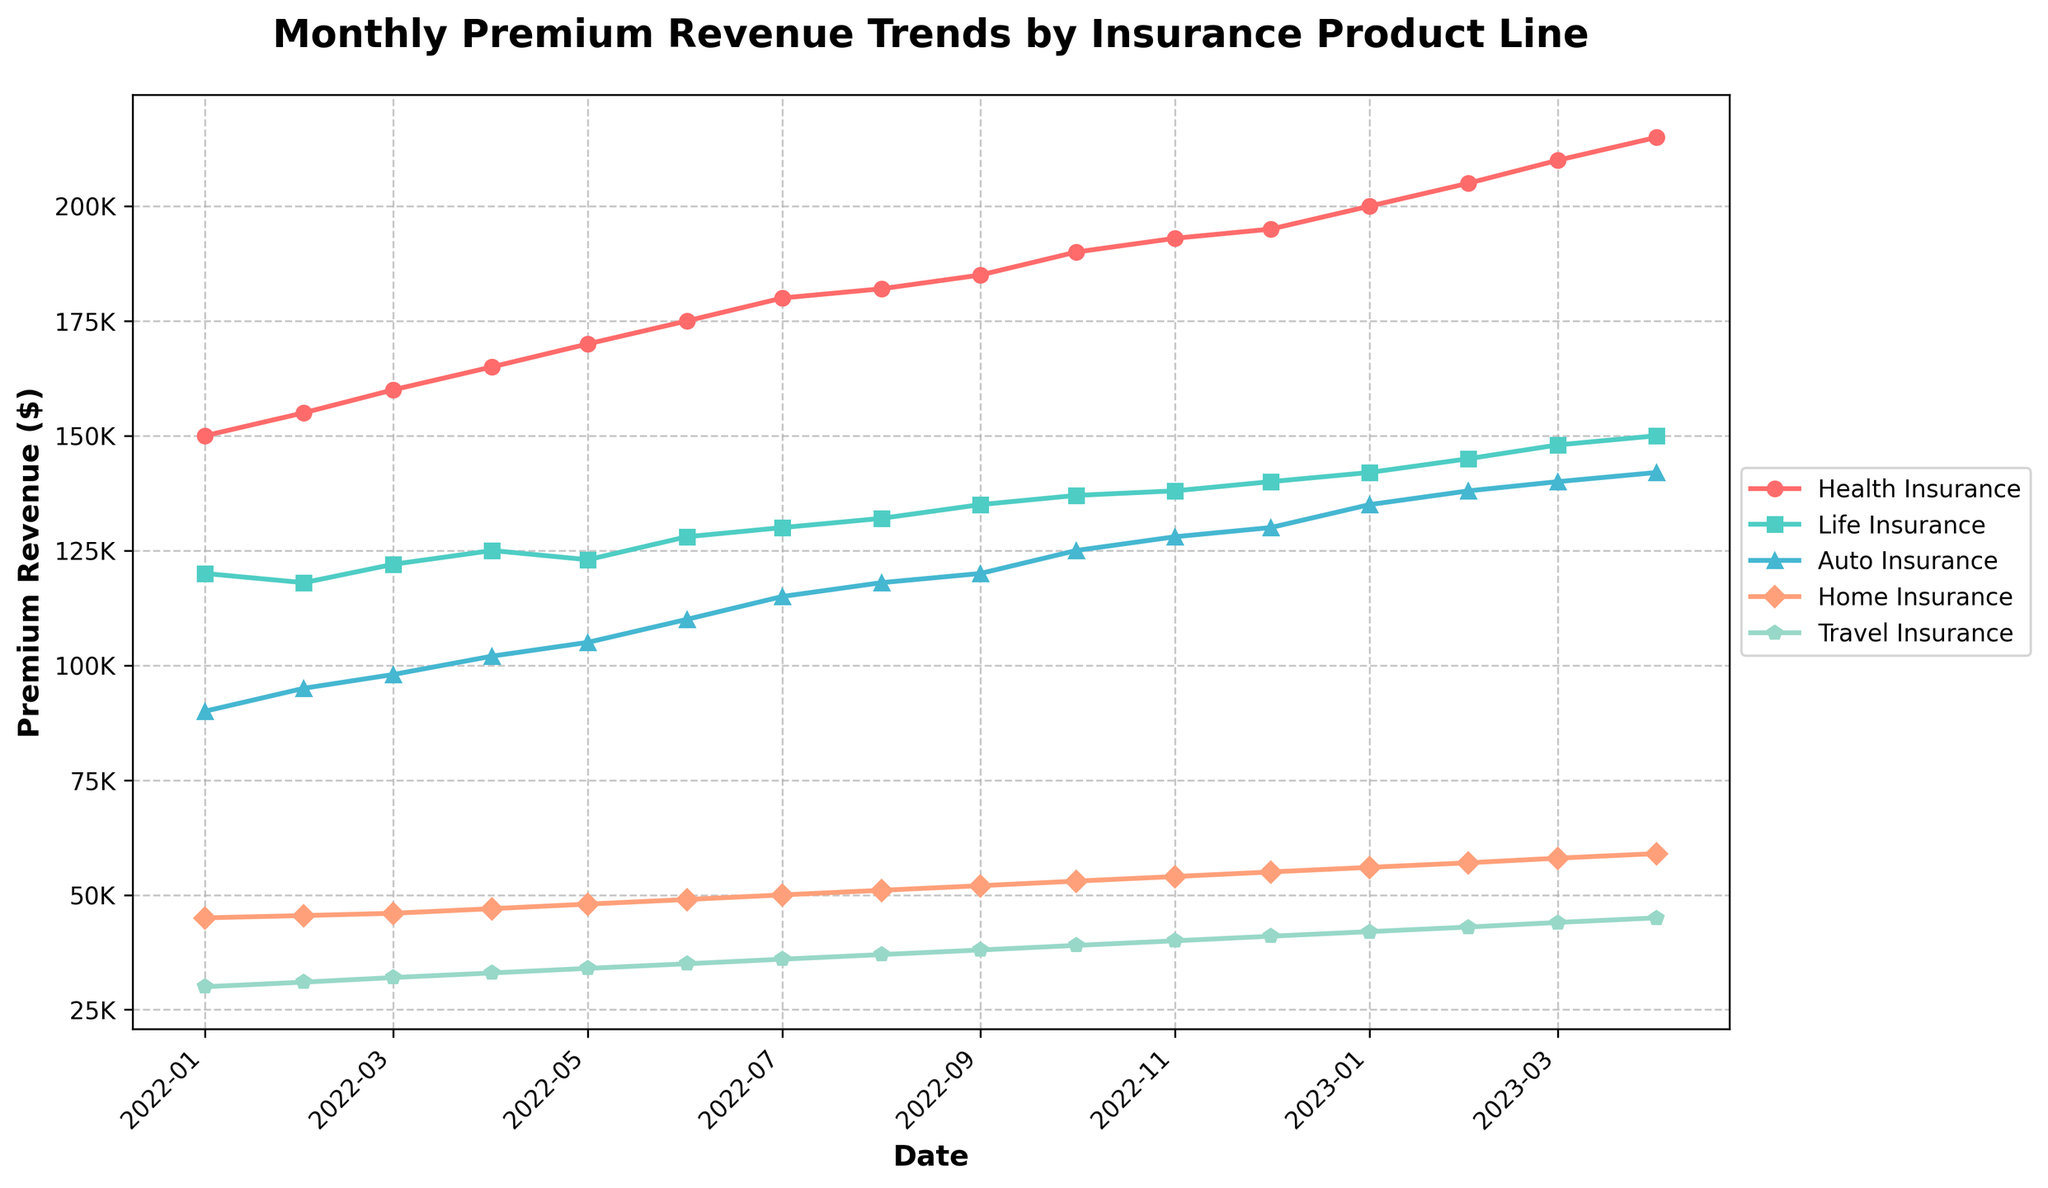What is the title of the plot? The title of the plot is displayed at the top center of the figure. Its purpose is to summarize what the figure shows. In this case, the title states "Monthly Premium Revenue Trends by Insurance Product Line."
Answer: Monthly Premium Revenue Trends by Insurance Product Line What is the date range covered in the time series plot? The x-axis represents the date range. It starts from the first month shown, "2022-01," and ends at the last month shown, "2023-04." This provides a timeline of data over approximately 16 months.
Answer: 2022-01 to 2023-04 Which insurance product line has the highest premium revenue in April 2023? By looking at the data points for April 2023 across all product lines, we can compare their values. "Health Insurance" has the highest value among the five product lines in April 2023 with a revenue of $215,000.
Answer: Health Insurance How does the premium revenue for "Auto Insurance" in January 2023 compare to that of December 2022? Find the values for "Auto Insurance" in December 2022 and January 2023. In December 2022, the revenue is $130,000, and in January 2023, it is $135,000. The revenue increased by $5,000.
Answer: Increased by $5,000 On average, how much did the monthly premium revenue for "Home Insurance" increase per month over the period shown? Calculate the difference between the final and initial revenues of "Home Insurance" and then divide by the number of months. Initial revenue in January 2022 is $45,000, and the final revenue in April 2023 is $59,000. The difference is $59,000 - $45,000 = $14,000. The average monthly increase: $14,000 / 16 months = $875.
Answer: $875 Which two insurance product lines showed the most similar trends over the period displayed? By visually comparing the lines on the plot, "Life Insurance" and "Travel Insurance" have similar trends as they both show a steady increase and follow similar patterns in the increase rate.
Answer: Life Insurance and Travel Insurance What was the percentage increase in premium revenue for "Health Insurance" from January 2022 to April 2023? Calculate the difference between the values in January 2022 and April 2023 and then find the percentage increase. Revenue in January 2022 is $150,000 and in April 2023 is $215,000. The increase is $215,000 - $150,000 = $65,000. Percentage increase: ($65,000 / $150,000) * 100 = 43.3%.
Answer: 43.3% Did any insurance product line show a decrease in premium revenue at any point during the time frame? By examining the plot lines, none of the insurance product lines show any points where the premium revenue decreases. All trends are upward over the entire time frame.
Answer: No Between which two consecutive months did "Travel Insurance" experience the highest revenue increase? By examining the "Travel Insurance" line, the highest increase is between March 2023 and April 2023. The revenue increased from $44,000 to $45,000, an increase of $1,000.
Answer: March 2023 and April 2023 